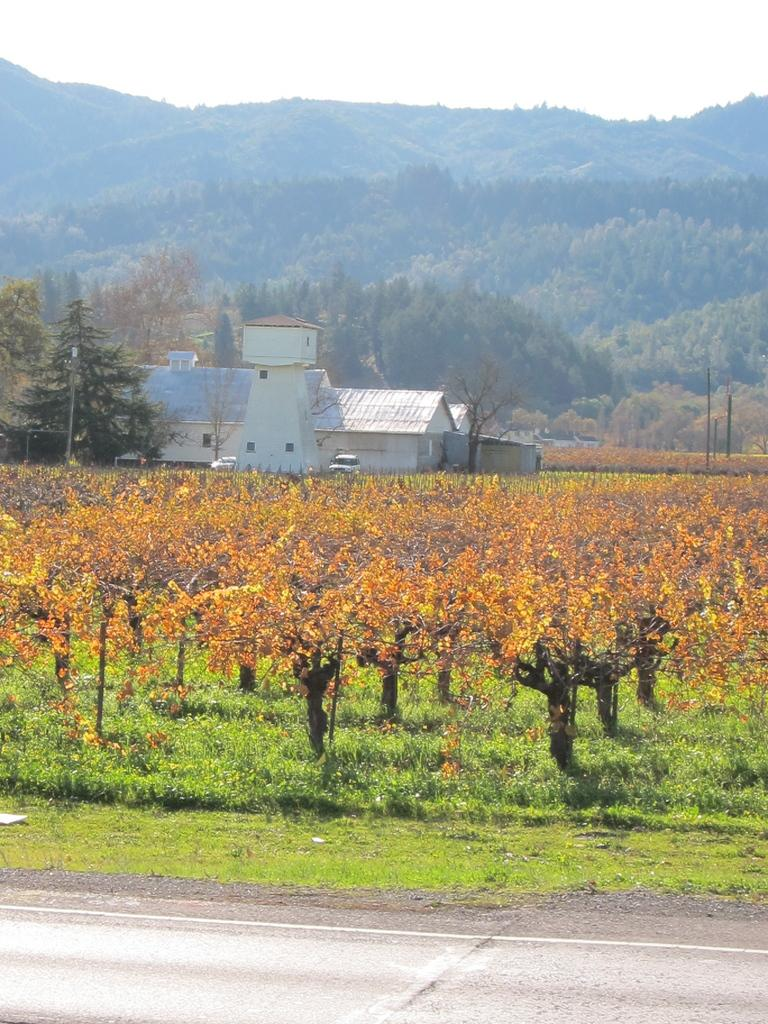What type of pathway can be seen in the image? There is a road in the image. What type of vegetation is present in the image? There are trees and grass in the image. What type of transportation can be seen in the image? There are vehicles in the image. What type of structures are present in the image? There are poles and buildings in the image. What type of natural landform is visible in the image? There are mountains in the image. What is visible in the background of the image? The sky is visible in the background of the image. What type of division can be seen between the trees and the grass in the image? There is no division between the trees and the grass in the image; they are both present in the same area. What type of mark can be seen on the vehicles in the image? There is no specific mark mentioned on the vehicles in the image; only their presence is noted. 